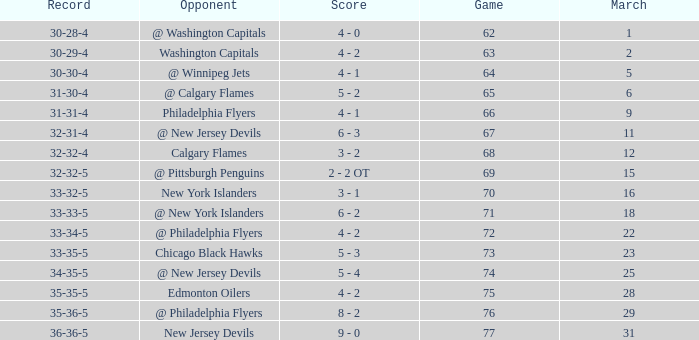How many games ended in a record of 30-28-4, with a March more than 1? 0.0. 